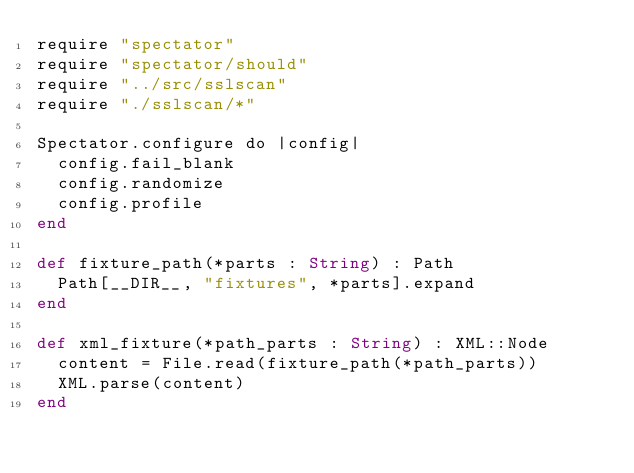<code> <loc_0><loc_0><loc_500><loc_500><_Crystal_>require "spectator"
require "spectator/should"
require "../src/sslscan"
require "./sslscan/*"

Spectator.configure do |config|
  config.fail_blank
  config.randomize
  config.profile
end

def fixture_path(*parts : String) : Path
  Path[__DIR__, "fixtures", *parts].expand
end

def xml_fixture(*path_parts : String) : XML::Node
  content = File.read(fixture_path(*path_parts))
  XML.parse(content)
end
</code> 